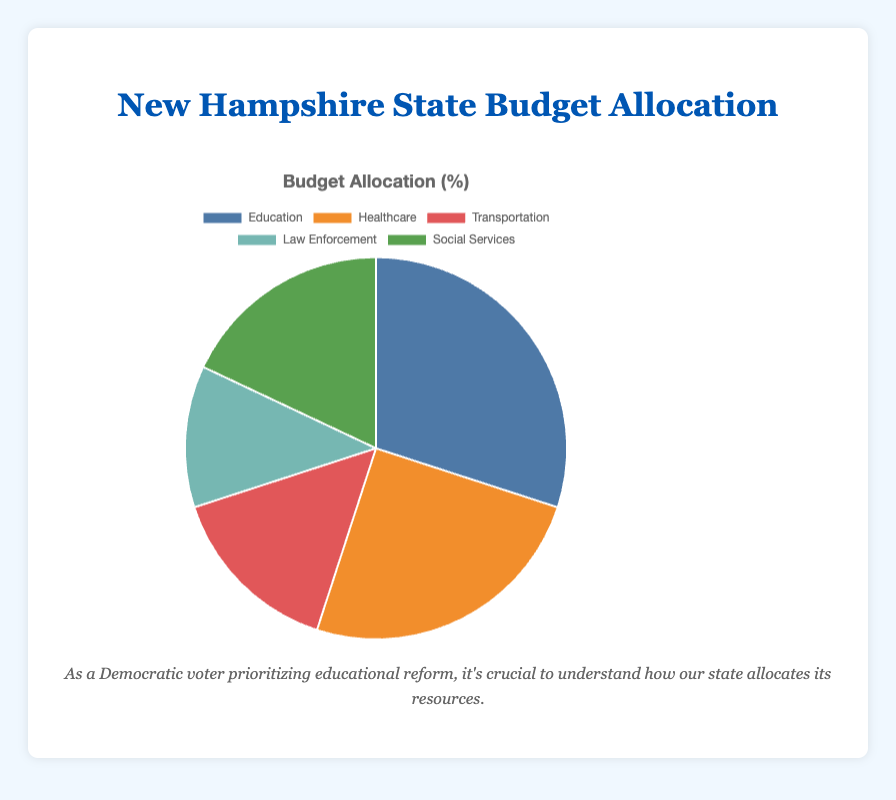What is the percentage allocation for education in the state budget? To find the percentage allocation for education, refer to the pie chart where each sector's percentage is labeled. Education sector is allocated 30% of the state budget.
Answer: 30% How much more is allocated to education compared to transportation? To determine the difference in allocation between education and transportation, subtract the percentage allocation for transportation from that of education: 30% - 15% = 15%.
Answer: 15% Which sector receives the least amount of the state budget? Look at the pie chart to identify the sector with the smallest percentage. Law Enforcement receives the least amount with 12%.
Answer: Law Enforcement Is social services' allocation more than transportation's? Compare the percentage allocations of social services and transportation. Social Services has 18%, and Transportation has 15%, so Social Services' allocation is more.
Answer: Yes What is the total combined budget allocation for healthcare and social services? Add the percentage allocations for healthcare and social services: 25% + 18% = 43%.
Answer: 43% Which sector has larger allocation: law enforcement or transportation? By comparing the percentages for law enforcement (12%) and transportation (15%), we see that transportation has a larger allocation.
Answer: Transportation What percentage of the budget is allocated to sectors other than healthcare and education? Subtract the combined percentage allocation for healthcare and education from 100%: 100% - (25% + 30%) = 45%.
Answer: 45% Which sector’s allocation is closest to a fifth of the total budget? A fifth of the total budget is 20%. Compare each sector’s allocation to this value. Social Services, with an 18% allocation, is closest to a fifth of the total budget.
Answer: Social Services If the state decided to increase the education budget by 5%, what would the new allocation percentage be? Add 5% to the current education allocation: 30% + 5% = 35%.
Answer: 35% Compare the combined percentage allocation of law enforcement and transportation to the allocation for education. Which is larger? Add the allocations for law enforcement and transportation: 12% + 15% = 27%. Since education receives 30%, education has a larger allocation.
Answer: Education 